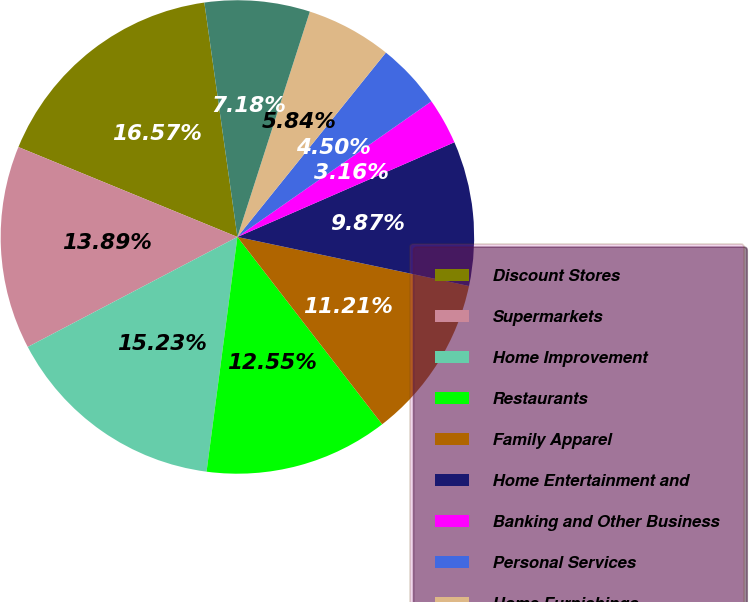Convert chart. <chart><loc_0><loc_0><loc_500><loc_500><pie_chart><fcel>Discount Stores<fcel>Supermarkets<fcel>Home Improvement<fcel>Restaurants<fcel>Family Apparel<fcel>Home Entertainment and<fcel>Banking and Other Business<fcel>Personal Services<fcel>Home Furnishings<fcel>Women's Apparel<nl><fcel>16.57%<fcel>13.89%<fcel>15.23%<fcel>12.55%<fcel>11.21%<fcel>9.87%<fcel>3.16%<fcel>4.5%<fcel>5.84%<fcel>7.18%<nl></chart> 